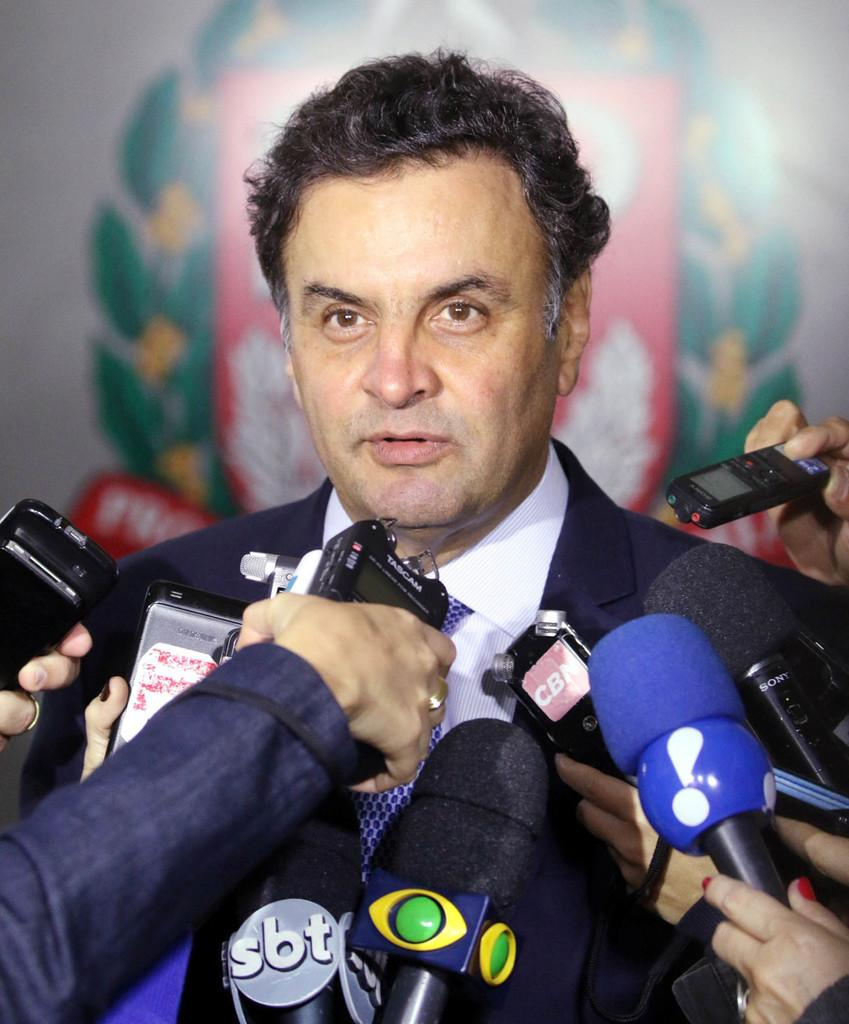Who is the main subject in the image? There is a man in the middle of the image. What are the persons in front of the man doing? They are holding microphones in front of the man. What can be seen in the background of the image? There is a banner in the background of the image. What type of crate is being used to store the war supplies in the image? There is no crate or war supplies present in the image; it features a man with persons holding microphones in front of him and a banner in the background. 